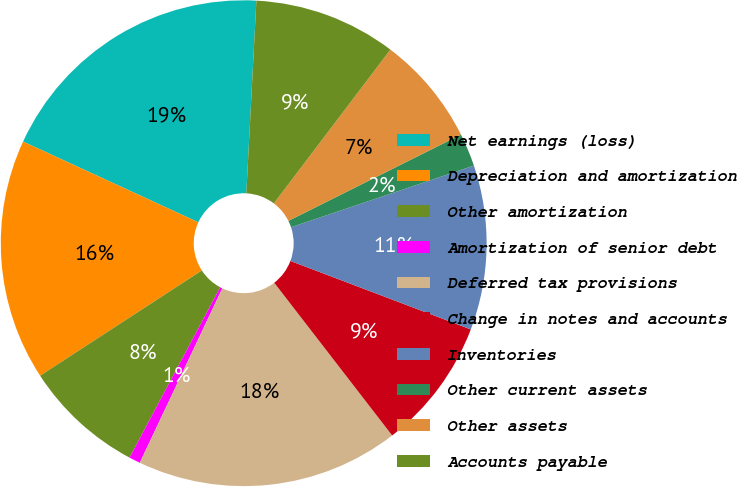Convert chart to OTSL. <chart><loc_0><loc_0><loc_500><loc_500><pie_chart><fcel>Net earnings (loss)<fcel>Depreciation and amortization<fcel>Other amortization<fcel>Amortization of senior debt<fcel>Deferred tax provisions<fcel>Change in notes and accounts<fcel>Inventories<fcel>Other current assets<fcel>Other assets<fcel>Accounts payable<nl><fcel>18.96%<fcel>16.05%<fcel>8.03%<fcel>0.75%<fcel>17.5%<fcel>8.76%<fcel>10.95%<fcel>2.2%<fcel>7.3%<fcel>9.49%<nl></chart> 